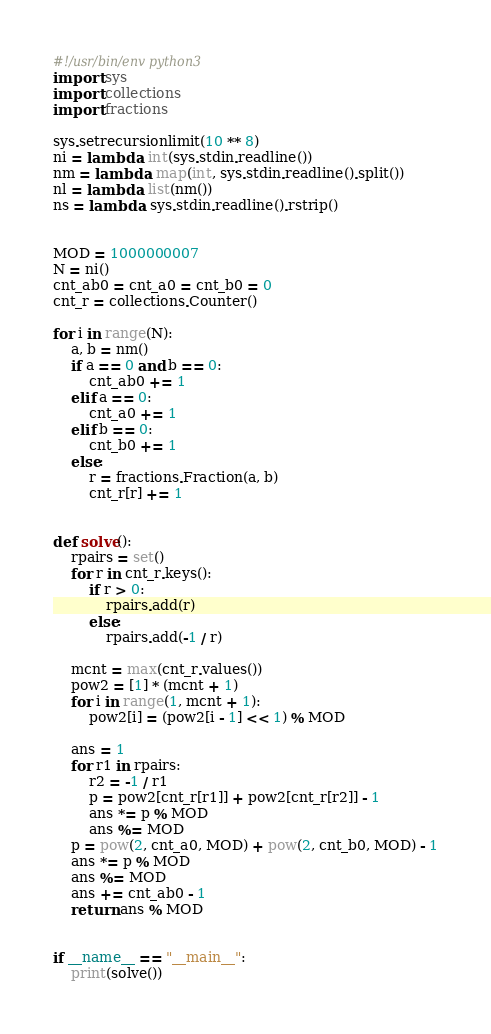<code> <loc_0><loc_0><loc_500><loc_500><_Python_>#!/usr/bin/env python3
import sys
import collections
import fractions

sys.setrecursionlimit(10 ** 8)
ni = lambda: int(sys.stdin.readline())
nm = lambda: map(int, sys.stdin.readline().split())
nl = lambda: list(nm())
ns = lambda: sys.stdin.readline().rstrip()


MOD = 1000000007
N = ni()
cnt_ab0 = cnt_a0 = cnt_b0 = 0
cnt_r = collections.Counter()

for i in range(N):
    a, b = nm()
    if a == 0 and b == 0:
        cnt_ab0 += 1
    elif a == 0:
        cnt_a0 += 1
    elif b == 0:
        cnt_b0 += 1
    else:
        r = fractions.Fraction(a, b)
        cnt_r[r] += 1


def solve():
    rpairs = set()
    for r in cnt_r.keys():
        if r > 0:
            rpairs.add(r)
        else:
            rpairs.add(-1 / r)

    mcnt = max(cnt_r.values())
    pow2 = [1] * (mcnt + 1)
    for i in range(1, mcnt + 1):
        pow2[i] = (pow2[i - 1] << 1) % MOD

    ans = 1
    for r1 in rpairs:
        r2 = -1 / r1
        p = pow2[cnt_r[r1]] + pow2[cnt_r[r2]] - 1
        ans *= p % MOD
        ans %= MOD
    p = pow(2, cnt_a0, MOD) + pow(2, cnt_b0, MOD) - 1
    ans *= p % MOD
    ans %= MOD
    ans += cnt_ab0 - 1
    return ans % MOD


if __name__ == "__main__":
    print(solve())
</code> 